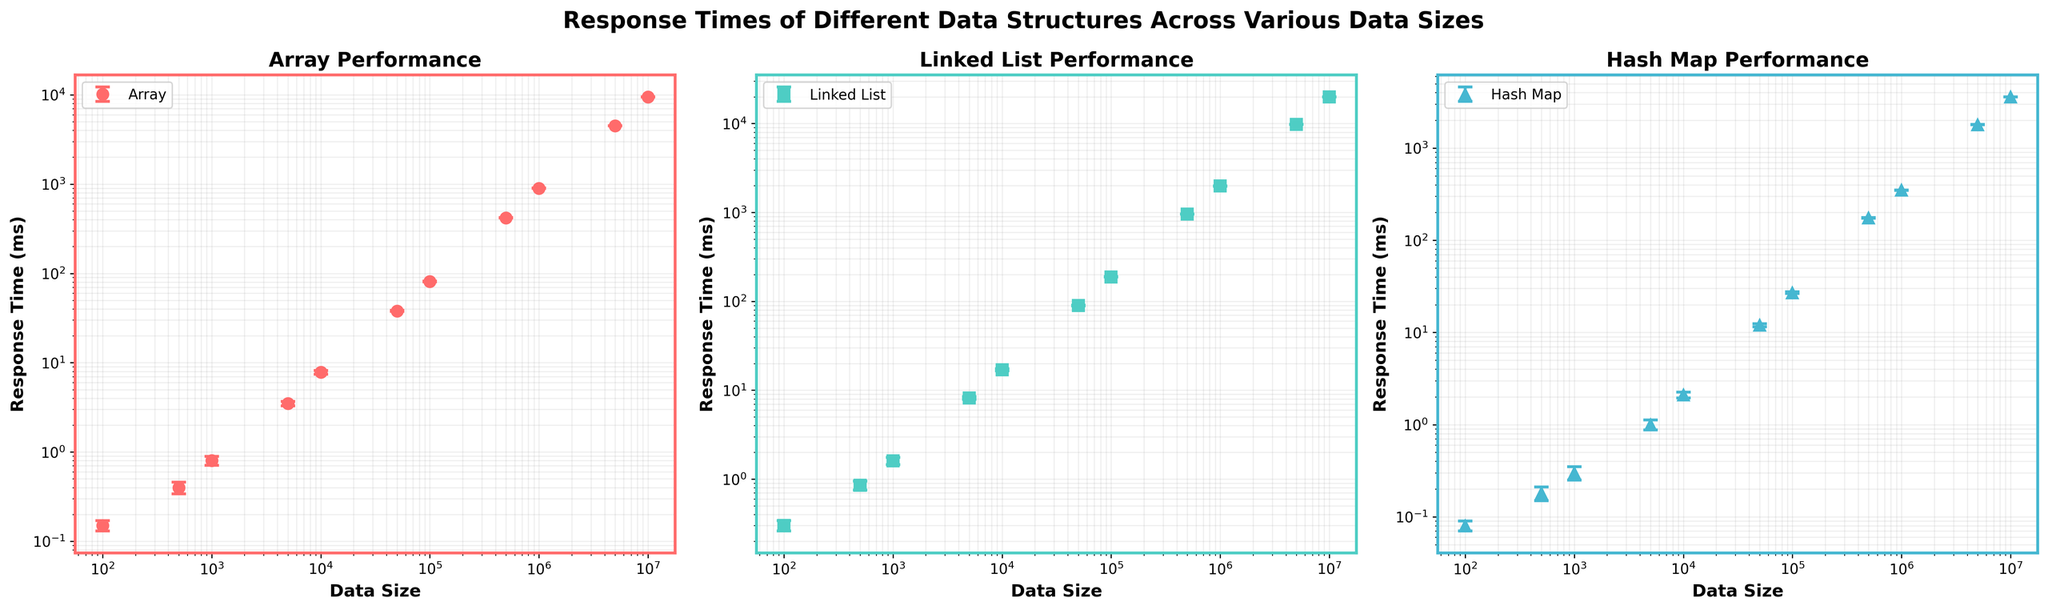What is the data size with the highest response time for the Array? The subplot for Array Performance shows response times across different data sizes. The highest response time is at the largest data size on the x-axis.
Answer: 10,000,000 What are the data sizes depicted in the figure? The x-axis of each subplot indicates the data sizes tested. Listing these gives us the data sizes.
Answer: 100, 500, 1000, 5000, 10000, 50000, 100000, 500000, 1000000, 5000000, 10000000 Which data structure shows the largest variation in response times across all data sizes? Comparing the error bars for each subplot, the Linked List shows the largest and most frequent errors, indicating the largest variation.
Answer: Linked List For a data size of 5000, which data structure has the fastest response time? At data size 5000, comparing the y-values for each data structure, the Hash Map has the lowest response time.
Answer: Hash Map What trend can be observed in response times as data size increases for all data structures? In each subplot, as data size on the x-axis increases, the response time on the y-axis generally increases as well.
Answer: Increases For data sizes from 1000 to 50000, which data structure shows the most consistent performance? Checking the consistency of response times via the size of error bars, the Array has the smallest relative error bars, indicating more consistent performance.
Answer: Array At data size 10000000, which data structure has the highest response time and what is it approximately? Looking at the y-values at data size 10000000, the Linked List has the highest response time. Reading the approximate value from the plot, it's about 20000 ms.
Answer: Linked List, 20000 ms What is the relative difference in response times between Array and Linked List for a data size of 500,000? Observing the subplot values for 500,000, the Linked List has a response time of 955 ms and the Array has 420 ms. Difference is calculated as 955 - 420.
Answer: 535 ms Compare the response times for Hash Map and Array at a data size of 1,000,000. Which one is faster and by how much? For data size 1,000,000, the Hash Map has a response time of 350 ms and the Array has 900 ms. The Hash Map is faster by subtracting Hash Map time from Array time.
Answer: Hash Map, 550 ms What is the y-axis scale used in the subplots and why is it useful? The subplots use a log scale for the y-axis. This scale is useful for visualizing data that varies over several orders of magnitude, as it makes large ranges of values easier to compare.
Answer: Logarithmic scale 